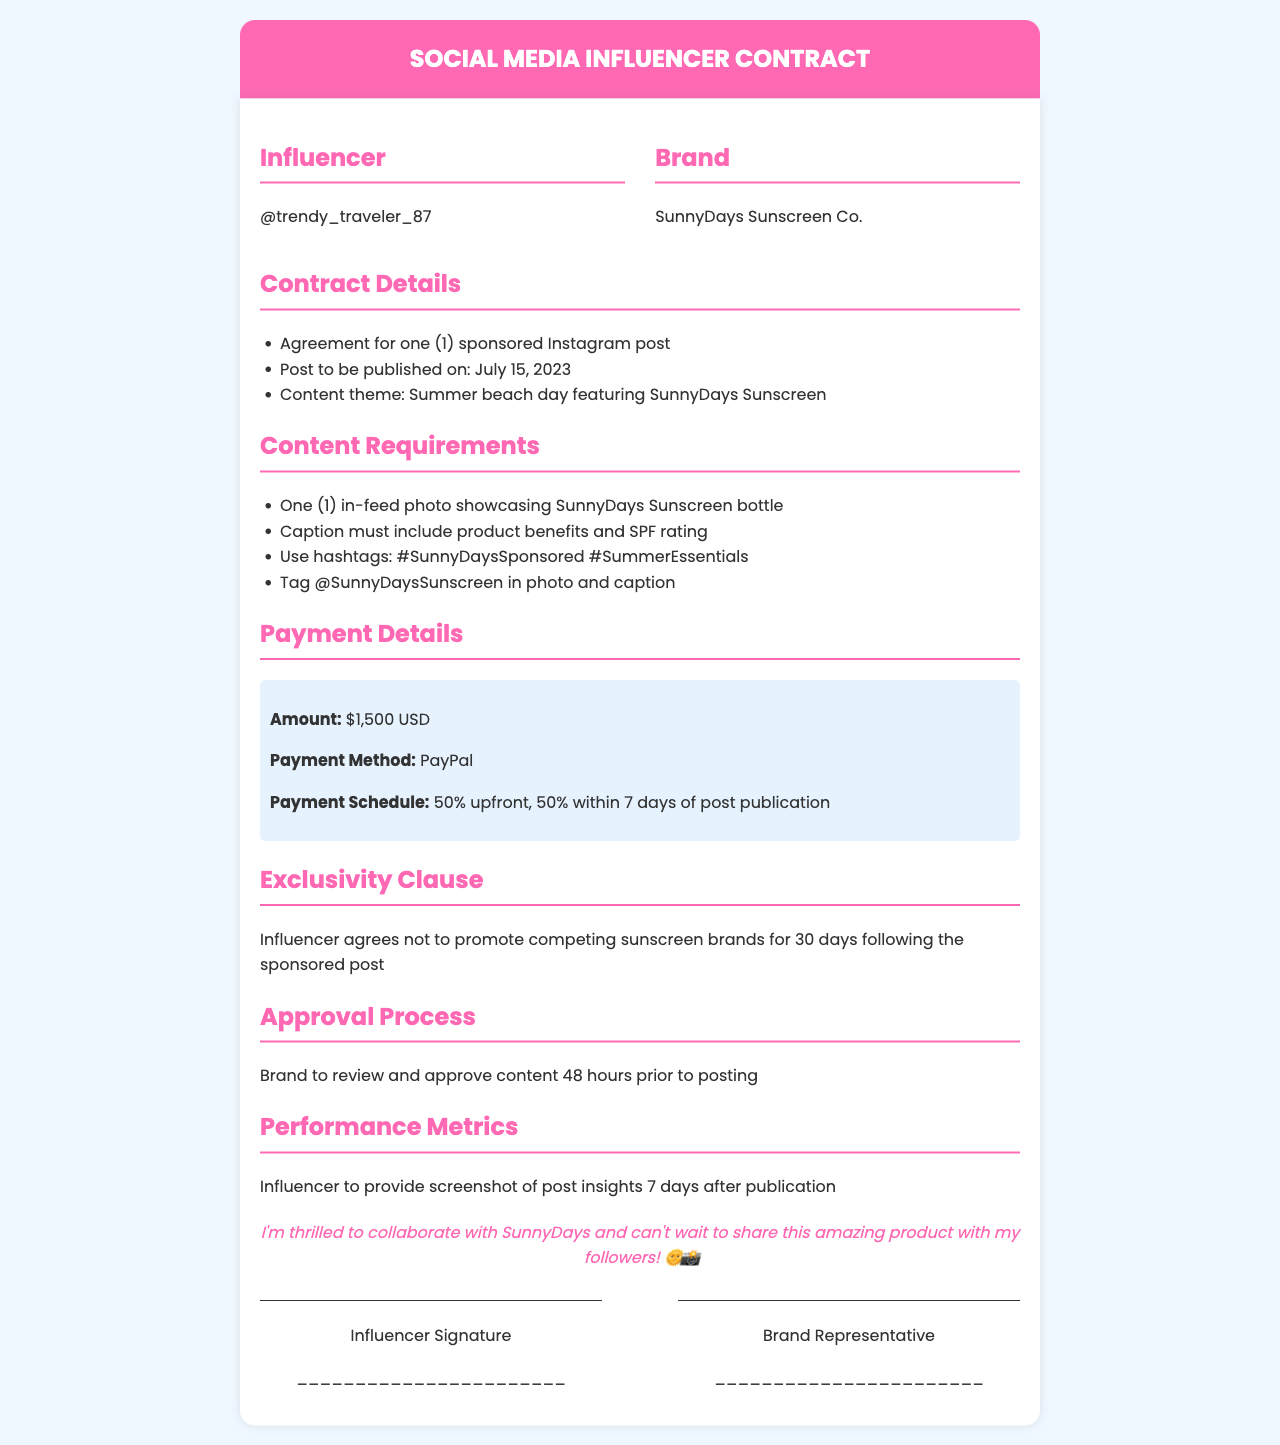What is the name of the influencer? The influencer's handle is listed as @trendy_traveler_87 in the document.
Answer: @trendy_traveler_87 What is the payment amount for the sponsored post? The payment amount specified in the contract is $1,500 USD.
Answer: $1,500 USD When is the post scheduled to be published? The document states the post is to be published on July 15, 2023.
Answer: July 15, 2023 What percentage of the payment is received upfront? The contract outlines that 50% of the total payment is to be received upfront.
Answer: 50% What is the exclusivity period after the post? The influencer must not promote competing brands for 30 days following the sponsored post.
Answer: 30 days What hashtags must be included in the post caption? The required hashtags stated in the document are #SunnyDaysSponsored and #SummerEssentials.
Answer: #SunnyDaysSponsored #SummerEssentials Who needs to approve the content before posting? The brand representative, SunnyDays Sunscreen Co., is responsible for reviewing and approving the content.
Answer: Brand What is the method of payment specified in the contract? The payment method mentioned for the transaction is PayPal.
Answer: PayPal What kind of content is required for the Instagram post? The contract requires one in-feed photo showcasing SunnyDays Sunscreen bottle.
Answer: One in-feed photo 